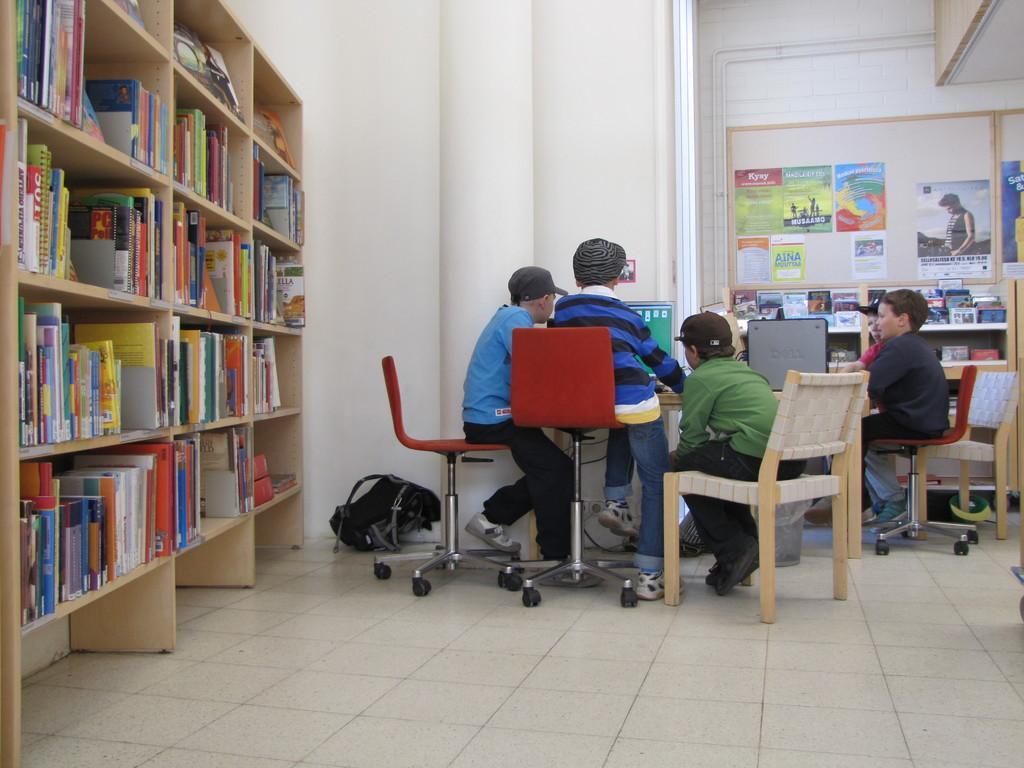In one or two sentences, can you explain what this image depicts? There are few people here sitting on the chair and looking at the computer. On the left there is a bookshelf in which many books are there. On the wall we can see posters. 